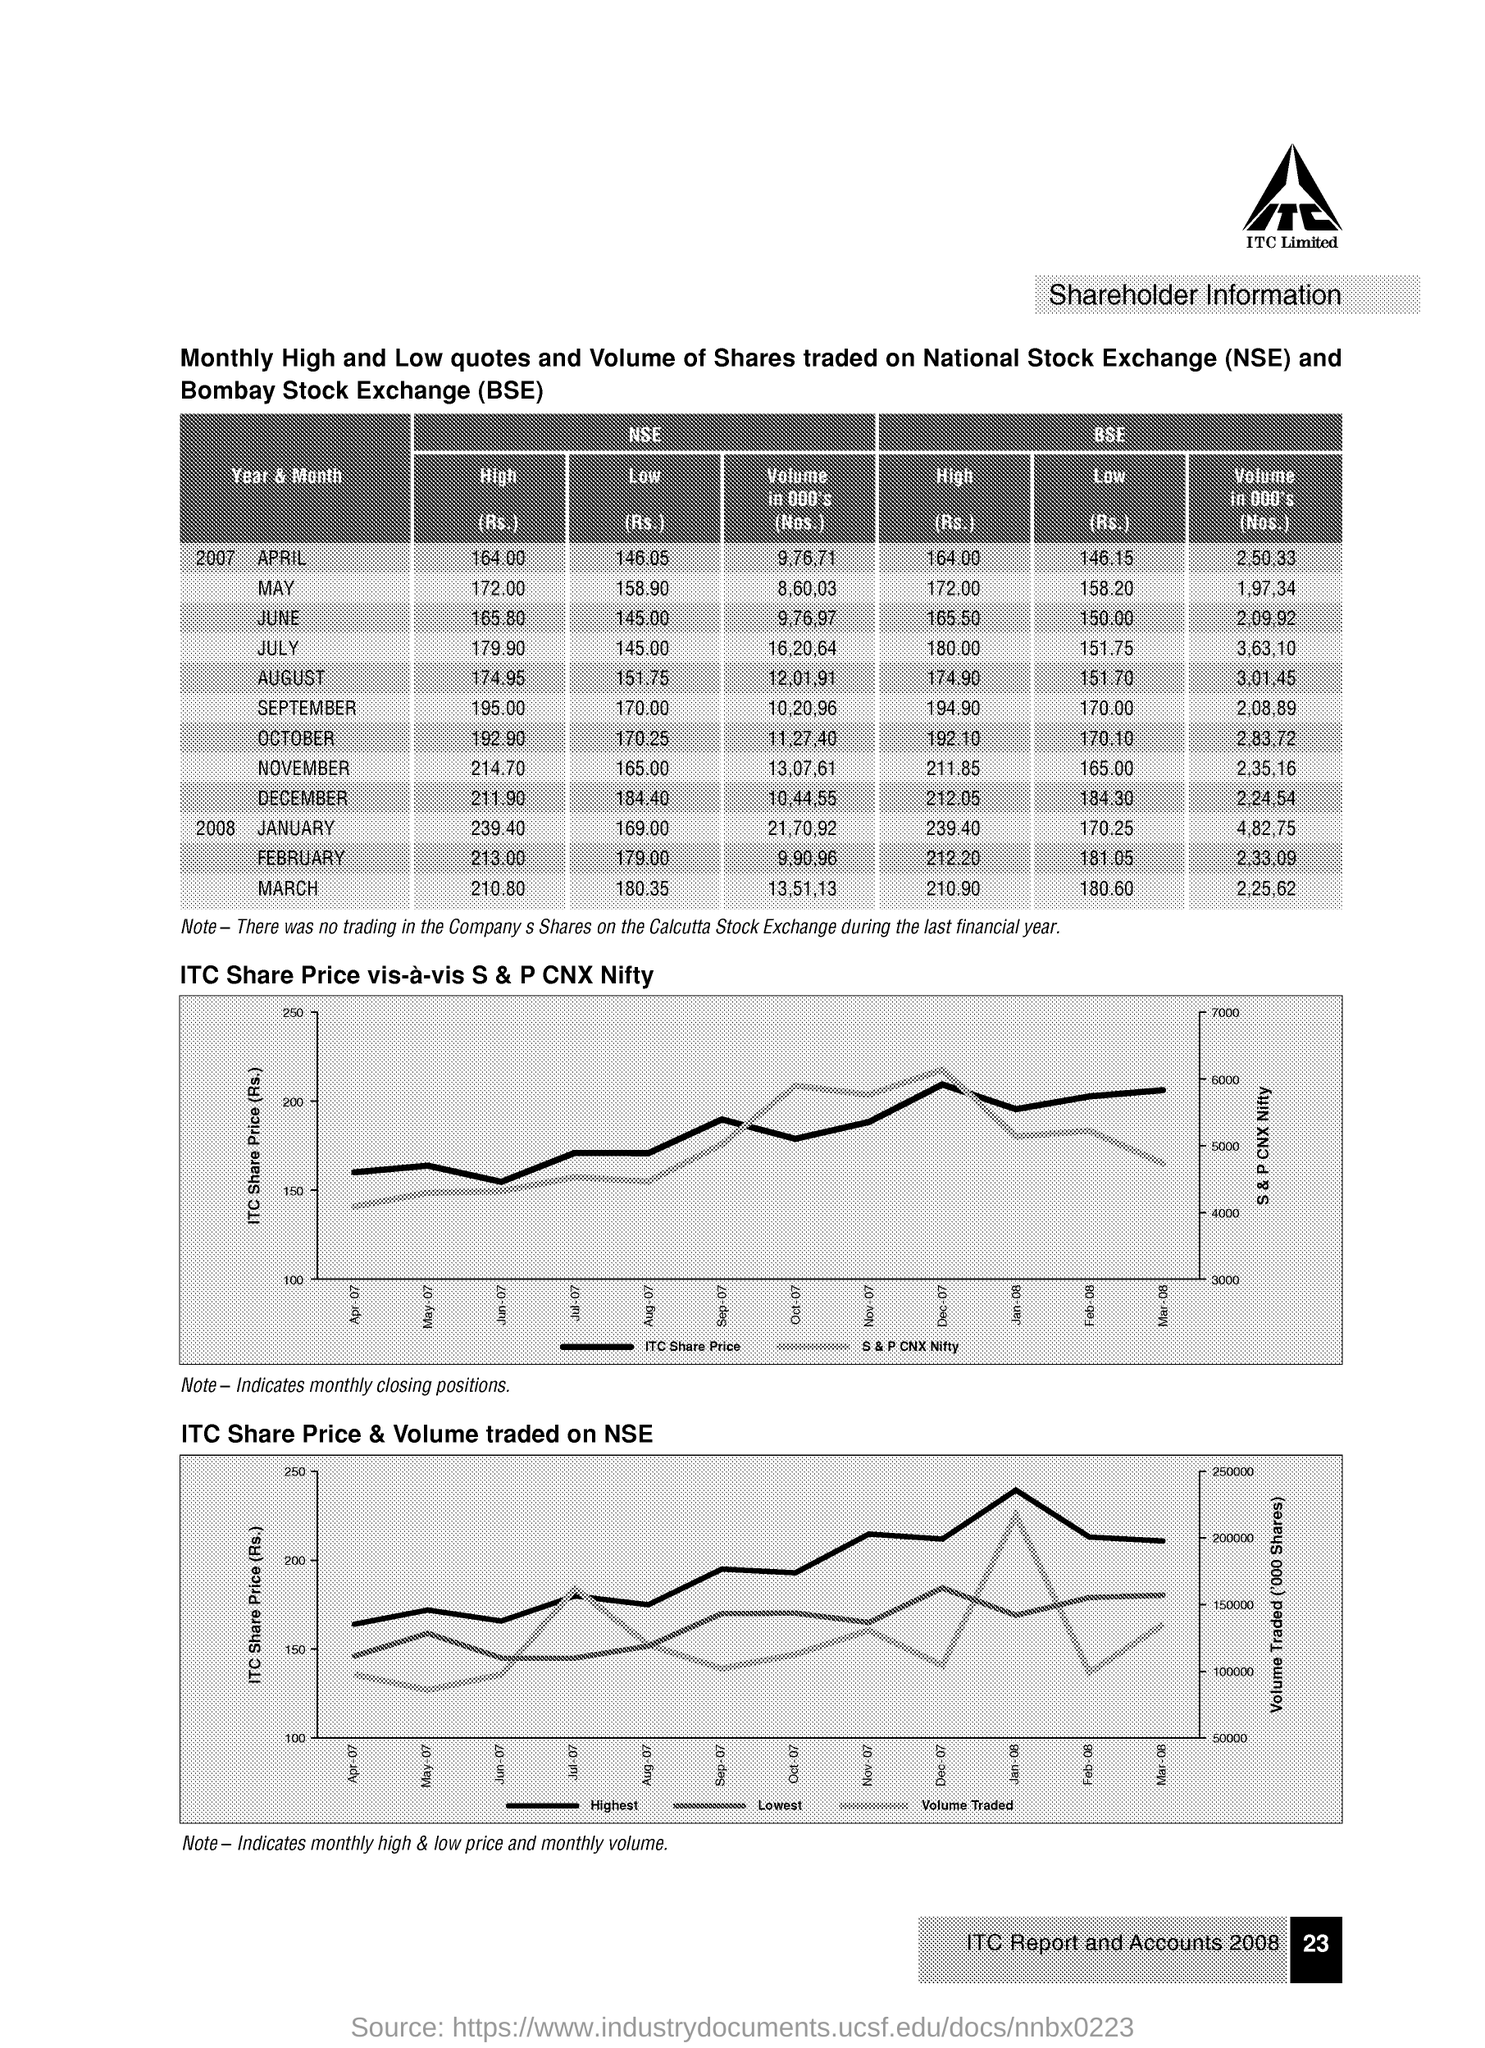What is the title of the second graph on the page?
Offer a terse response. ITC Share Price & Volume traded on NSE. 